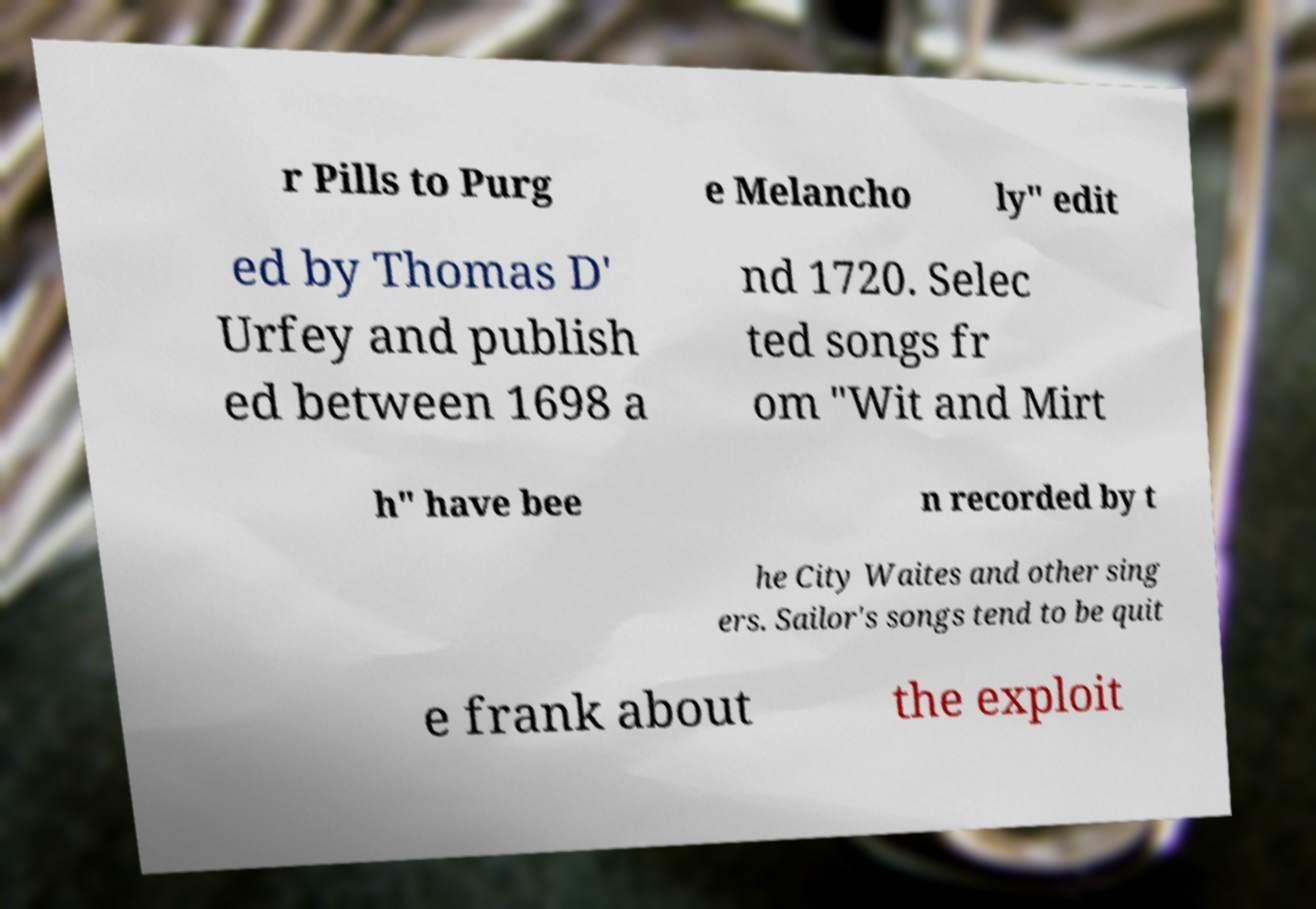What messages or text are displayed in this image? I need them in a readable, typed format. r Pills to Purg e Melancho ly" edit ed by Thomas D' Urfey and publish ed between 1698 a nd 1720. Selec ted songs fr om "Wit and Mirt h" have bee n recorded by t he City Waites and other sing ers. Sailor's songs tend to be quit e frank about the exploit 